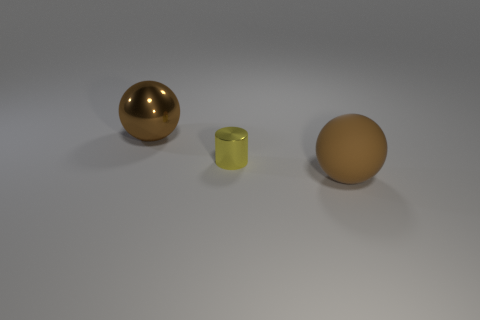What number of small objects are purple matte cylinders or brown rubber balls?
Keep it short and to the point. 0. What material is the object that is the same color as the big matte sphere?
Make the answer very short. Metal. Are there fewer tiny green metal cylinders than brown objects?
Provide a succinct answer. Yes. There is a brown ball in front of the big brown metal thing; is its size the same as the brown thing behind the tiny shiny cylinder?
Ensure brevity in your answer.  Yes. How many yellow objects are shiny cylinders or metallic things?
Your answer should be very brief. 1. There is a metallic object that is the same color as the rubber thing; what is its size?
Ensure brevity in your answer.  Large. Is the number of small yellow shiny objects greater than the number of tiny yellow rubber objects?
Ensure brevity in your answer.  Yes. Do the matte ball and the large shiny sphere have the same color?
Ensure brevity in your answer.  Yes. How many things are tiny red metallic cylinders or things on the left side of the big brown matte object?
Offer a terse response. 2. What number of other things are there of the same shape as the tiny yellow object?
Keep it short and to the point. 0. 